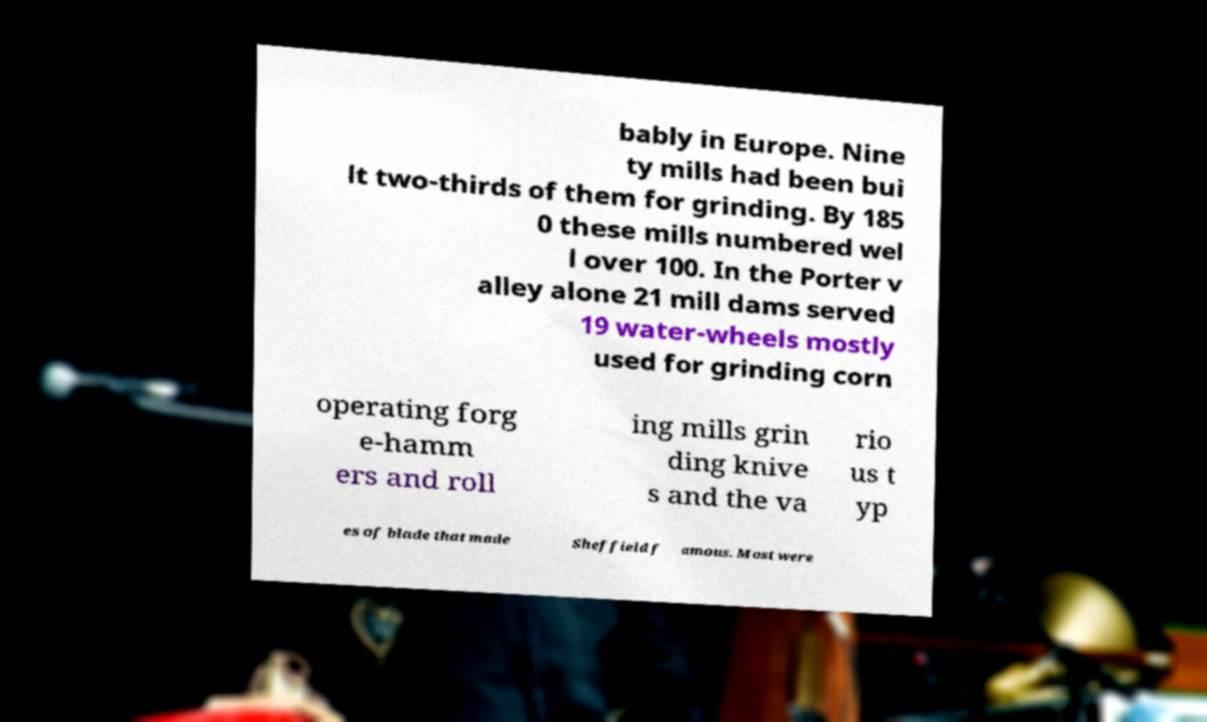What messages or text are displayed in this image? I need them in a readable, typed format. bably in Europe. Nine ty mills had been bui lt two-thirds of them for grinding. By 185 0 these mills numbered wel l over 100. In the Porter v alley alone 21 mill dams served 19 water-wheels mostly used for grinding corn operating forg e-hamm ers and roll ing mills grin ding knive s and the va rio us t yp es of blade that made Sheffield f amous. Most were 